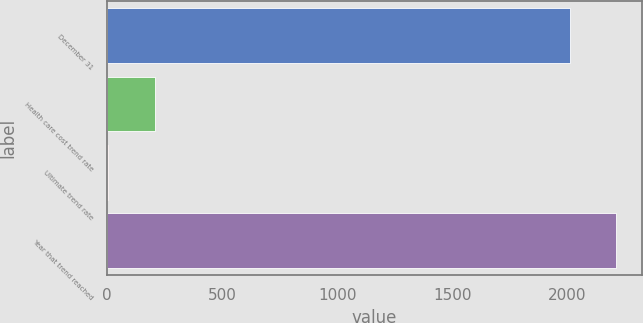<chart> <loc_0><loc_0><loc_500><loc_500><bar_chart><fcel>December 31<fcel>Health care cost trend rate<fcel>Ultimate trend rate<fcel>Year that trend reached<nl><fcel>2011<fcel>206.3<fcel>5<fcel>2212.3<nl></chart> 